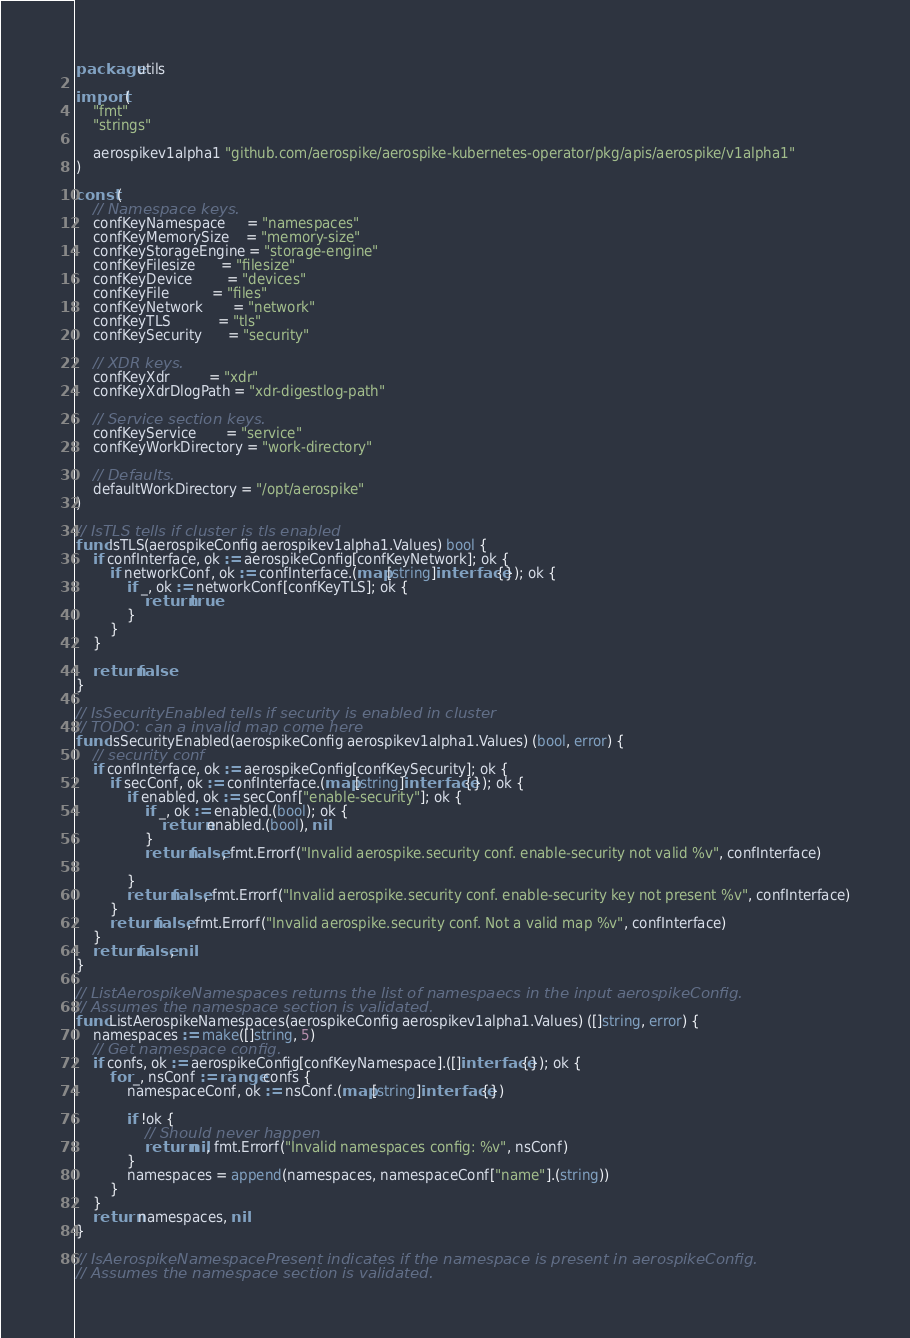Convert code to text. <code><loc_0><loc_0><loc_500><loc_500><_Go_>package utils

import (
	"fmt"
	"strings"

	aerospikev1alpha1 "github.com/aerospike/aerospike-kubernetes-operator/pkg/apis/aerospike/v1alpha1"
)

const (
	// Namespace keys.
	confKeyNamespace     = "namespaces"
	confKeyMemorySize    = "memory-size"
	confKeyStorageEngine = "storage-engine"
	confKeyFilesize      = "filesize"
	confKeyDevice        = "devices"
	confKeyFile          = "files"
	confKeyNetwork       = "network"
	confKeyTLS           = "tls"
	confKeySecurity      = "security"

	// XDR keys.
	confKeyXdr         = "xdr"
	confKeyXdrDlogPath = "xdr-digestlog-path"

	// Service section keys.
	confKeyService       = "service"
	confKeyWorkDirectory = "work-directory"

	// Defaults.
	defaultWorkDirectory = "/opt/aerospike"
)

// IsTLS tells if cluster is tls enabled
func IsTLS(aerospikeConfig aerospikev1alpha1.Values) bool {
	if confInterface, ok := aerospikeConfig[confKeyNetwork]; ok {
		if networkConf, ok := confInterface.(map[string]interface{}); ok {
			if _, ok := networkConf[confKeyTLS]; ok {
				return true
			}
		}
	}

	return false
}

// IsSecurityEnabled tells if security is enabled in cluster
// TODO: can a invalid map come here
func IsSecurityEnabled(aerospikeConfig aerospikev1alpha1.Values) (bool, error) {
	// security conf
	if confInterface, ok := aerospikeConfig[confKeySecurity]; ok {
		if secConf, ok := confInterface.(map[string]interface{}); ok {
			if enabled, ok := secConf["enable-security"]; ok {
				if _, ok := enabled.(bool); ok {
					return enabled.(bool), nil
				}
				return false, fmt.Errorf("Invalid aerospike.security conf. enable-security not valid %v", confInterface)

			}
			return false, fmt.Errorf("Invalid aerospike.security conf. enable-security key not present %v", confInterface)
		}
		return false, fmt.Errorf("Invalid aerospike.security conf. Not a valid map %v", confInterface)
	}
	return false, nil
}

// ListAerospikeNamespaces returns the list of namespaecs in the input aerospikeConfig.
// Assumes the namespace section is validated.
func ListAerospikeNamespaces(aerospikeConfig aerospikev1alpha1.Values) ([]string, error) {
	namespaces := make([]string, 5)
	// Get namespace config.
	if confs, ok := aerospikeConfig[confKeyNamespace].([]interface{}); ok {
		for _, nsConf := range confs {
			namespaceConf, ok := nsConf.(map[string]interface{})

			if !ok {
				// Should never happen
				return nil, fmt.Errorf("Invalid namespaces config: %v", nsConf)
			}
			namespaces = append(namespaces, namespaceConf["name"].(string))
		}
	}
	return namespaces, nil
}

// IsAerospikeNamespacePresent indicates if the namespace is present in aerospikeConfig.
// Assumes the namespace section is validated.</code> 